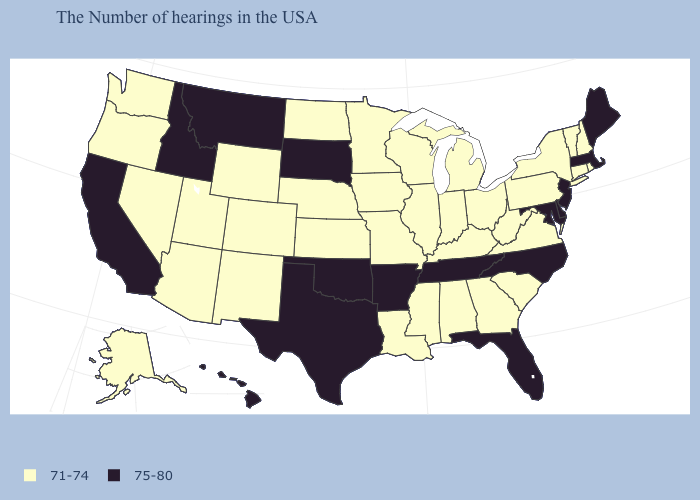Does Idaho have the highest value in the West?
Be succinct. Yes. Among the states that border Arizona , does California have the highest value?
Be succinct. Yes. What is the value of New Jersey?
Give a very brief answer. 75-80. Which states have the lowest value in the USA?
Give a very brief answer. Rhode Island, New Hampshire, Vermont, Connecticut, New York, Pennsylvania, Virginia, South Carolina, West Virginia, Ohio, Georgia, Michigan, Kentucky, Indiana, Alabama, Wisconsin, Illinois, Mississippi, Louisiana, Missouri, Minnesota, Iowa, Kansas, Nebraska, North Dakota, Wyoming, Colorado, New Mexico, Utah, Arizona, Nevada, Washington, Oregon, Alaska. Does Florida have the same value as Hawaii?
Be succinct. Yes. Which states hav the highest value in the West?
Short answer required. Montana, Idaho, California, Hawaii. Which states have the lowest value in the USA?
Be succinct. Rhode Island, New Hampshire, Vermont, Connecticut, New York, Pennsylvania, Virginia, South Carolina, West Virginia, Ohio, Georgia, Michigan, Kentucky, Indiana, Alabama, Wisconsin, Illinois, Mississippi, Louisiana, Missouri, Minnesota, Iowa, Kansas, Nebraska, North Dakota, Wyoming, Colorado, New Mexico, Utah, Arizona, Nevada, Washington, Oregon, Alaska. Does Montana have the highest value in the USA?
Be succinct. Yes. Name the states that have a value in the range 75-80?
Answer briefly. Maine, Massachusetts, New Jersey, Delaware, Maryland, North Carolina, Florida, Tennessee, Arkansas, Oklahoma, Texas, South Dakota, Montana, Idaho, California, Hawaii. Name the states that have a value in the range 71-74?
Keep it brief. Rhode Island, New Hampshire, Vermont, Connecticut, New York, Pennsylvania, Virginia, South Carolina, West Virginia, Ohio, Georgia, Michigan, Kentucky, Indiana, Alabama, Wisconsin, Illinois, Mississippi, Louisiana, Missouri, Minnesota, Iowa, Kansas, Nebraska, North Dakota, Wyoming, Colorado, New Mexico, Utah, Arizona, Nevada, Washington, Oregon, Alaska. What is the value of Missouri?
Be succinct. 71-74. Which states have the highest value in the USA?
Answer briefly. Maine, Massachusetts, New Jersey, Delaware, Maryland, North Carolina, Florida, Tennessee, Arkansas, Oklahoma, Texas, South Dakota, Montana, Idaho, California, Hawaii. Among the states that border Louisiana , does Mississippi have the lowest value?
Concise answer only. Yes. Name the states that have a value in the range 75-80?
Quick response, please. Maine, Massachusetts, New Jersey, Delaware, Maryland, North Carolina, Florida, Tennessee, Arkansas, Oklahoma, Texas, South Dakota, Montana, Idaho, California, Hawaii. 